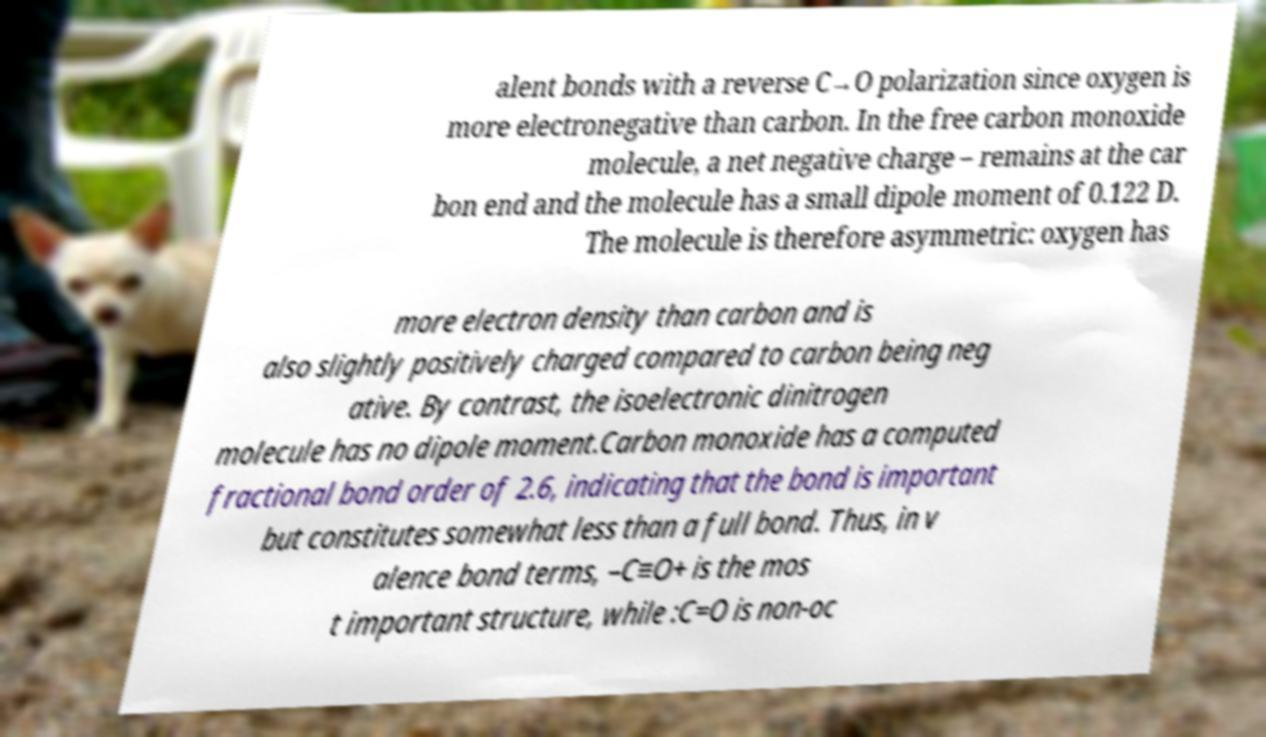Can you accurately transcribe the text from the provided image for me? alent bonds with a reverse C→O polarization since oxygen is more electronegative than carbon. In the free carbon monoxide molecule, a net negative charge – remains at the car bon end and the molecule has a small dipole moment of 0.122 D. The molecule is therefore asymmetric: oxygen has more electron density than carbon and is also slightly positively charged compared to carbon being neg ative. By contrast, the isoelectronic dinitrogen molecule has no dipole moment.Carbon monoxide has a computed fractional bond order of 2.6, indicating that the bond is important but constitutes somewhat less than a full bond. Thus, in v alence bond terms, –C≡O+ is the mos t important structure, while :C=O is non-oc 